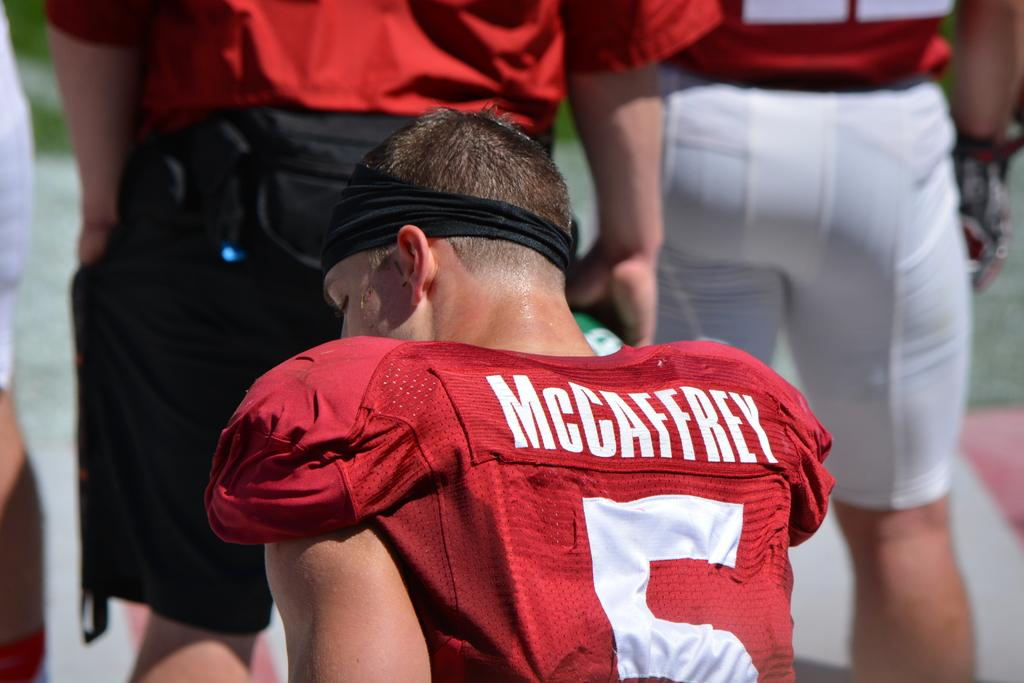Provide a one-sentence caption for the provided image. McCaffrey is player number 5 on this team with red uniforms. 